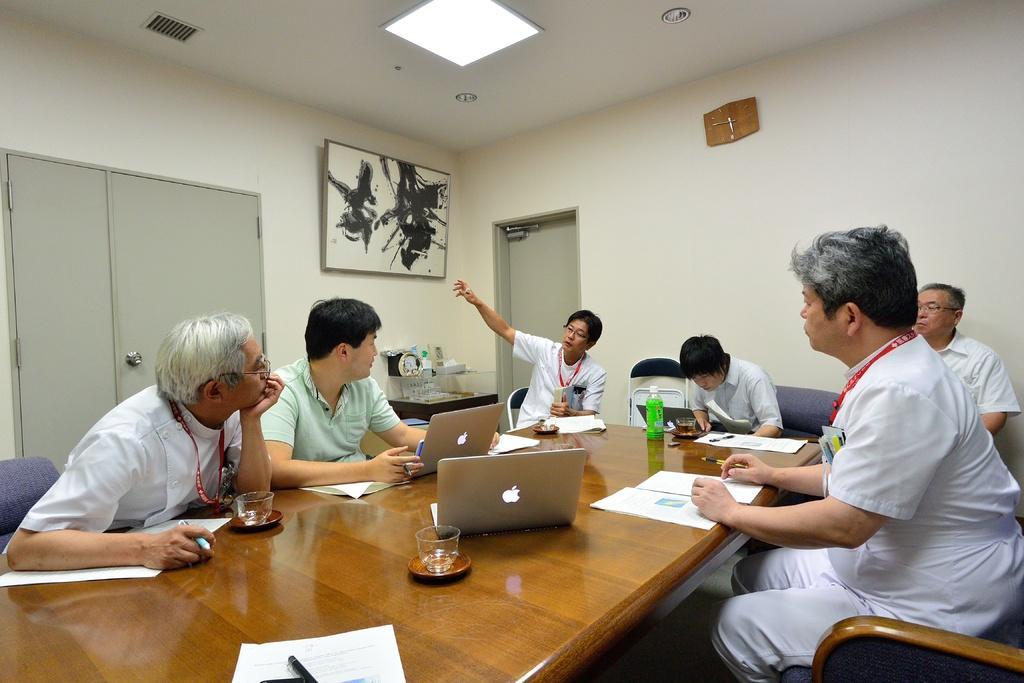Can you describe this image briefly? In this picture there are group of people who are sitting on the chair. There is a laptop, cup, saucer, pen, bottle on the table. There is a frame on the wall. There is a wall clock. There is a door, door handle. There are few objects on the table. 